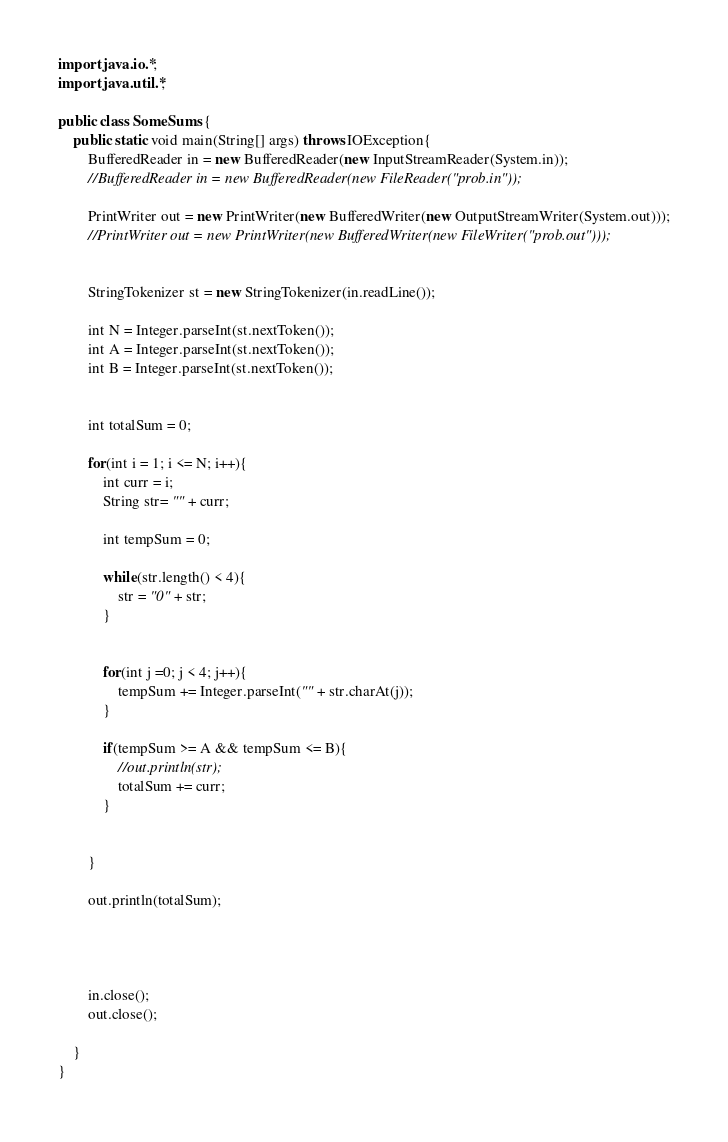<code> <loc_0><loc_0><loc_500><loc_500><_Java_>import java.io.*;
import java.util.*;

public class SomeSums {
	public static void main(String[] args) throws IOException{
		BufferedReader in = new BufferedReader(new InputStreamReader(System.in));
		//BufferedReader in = new BufferedReader(new FileReader("prob.in"));
		
		PrintWriter out = new PrintWriter(new BufferedWriter(new OutputStreamWriter(System.out)));
		//PrintWriter out = new PrintWriter(new BufferedWriter(new FileWriter("prob.out")));
		
		
		StringTokenizer st = new StringTokenizer(in.readLine());
		
		int N = Integer.parseInt(st.nextToken());
		int A = Integer.parseInt(st.nextToken());
		int B = Integer.parseInt(st.nextToken());
		
		
		int totalSum = 0;
		
		for(int i = 1; i <= N; i++){
			int curr = i;
			String str= "" + curr;
			
			int tempSum = 0;
			
			while(str.length() < 4){
				str = "0" + str;
			}
			
			
			for(int j =0; j < 4; j++){
				tempSum += Integer.parseInt("" + str.charAt(j));
			}
			
			if(tempSum >= A && tempSum <= B){
				//out.println(str);
				totalSum += curr;
			}
			
			
		}
		
		out.println(totalSum);
		
		
		
		
		in.close();
		out.close();
		
	}
}
</code> 